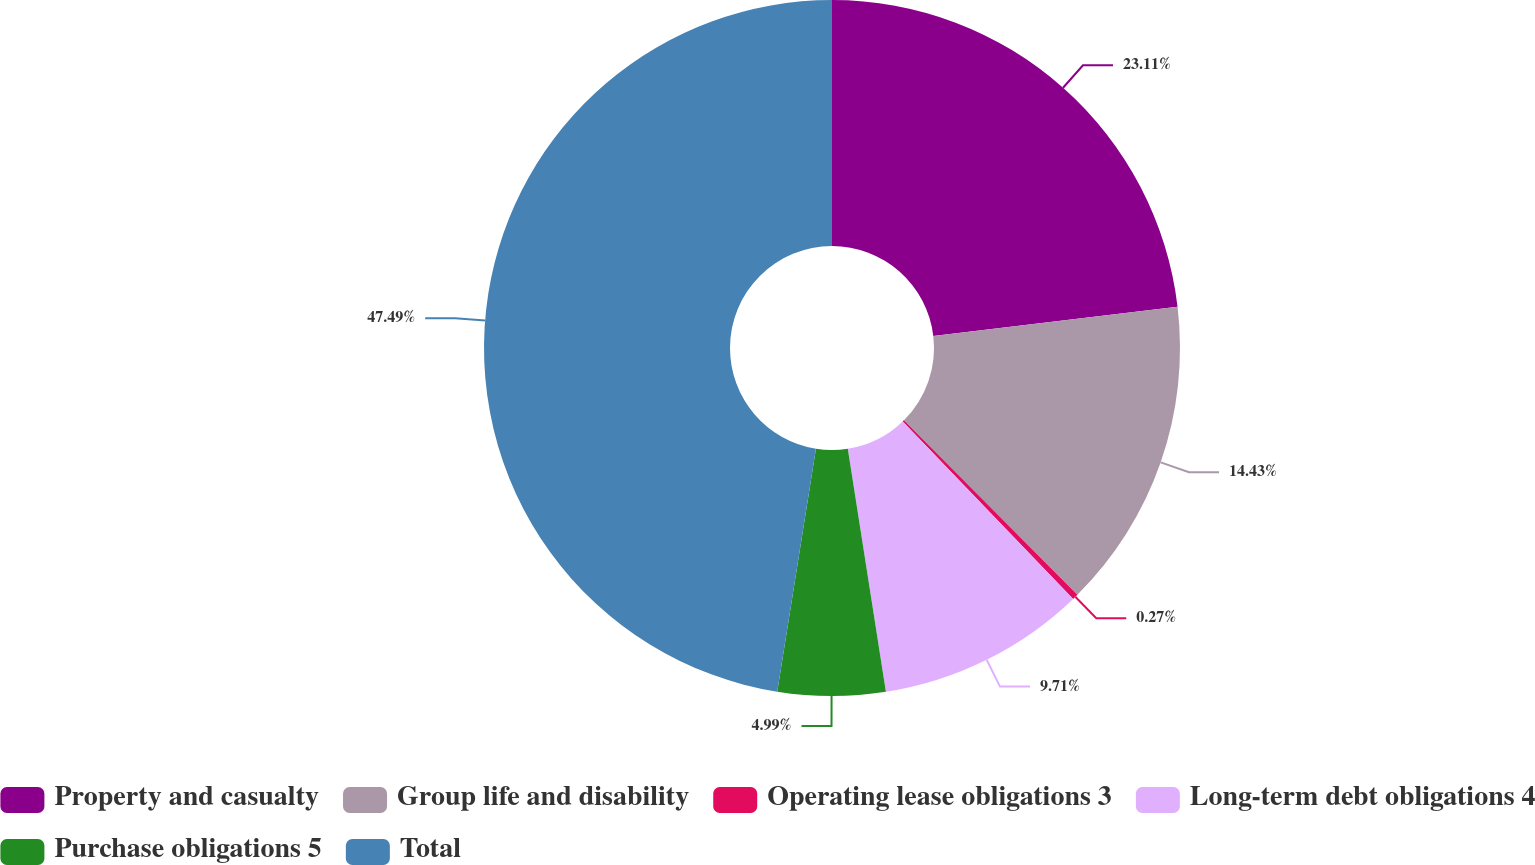Convert chart to OTSL. <chart><loc_0><loc_0><loc_500><loc_500><pie_chart><fcel>Property and casualty<fcel>Group life and disability<fcel>Operating lease obligations 3<fcel>Long-term debt obligations 4<fcel>Purchase obligations 5<fcel>Total<nl><fcel>23.11%<fcel>14.43%<fcel>0.27%<fcel>9.71%<fcel>4.99%<fcel>47.48%<nl></chart> 